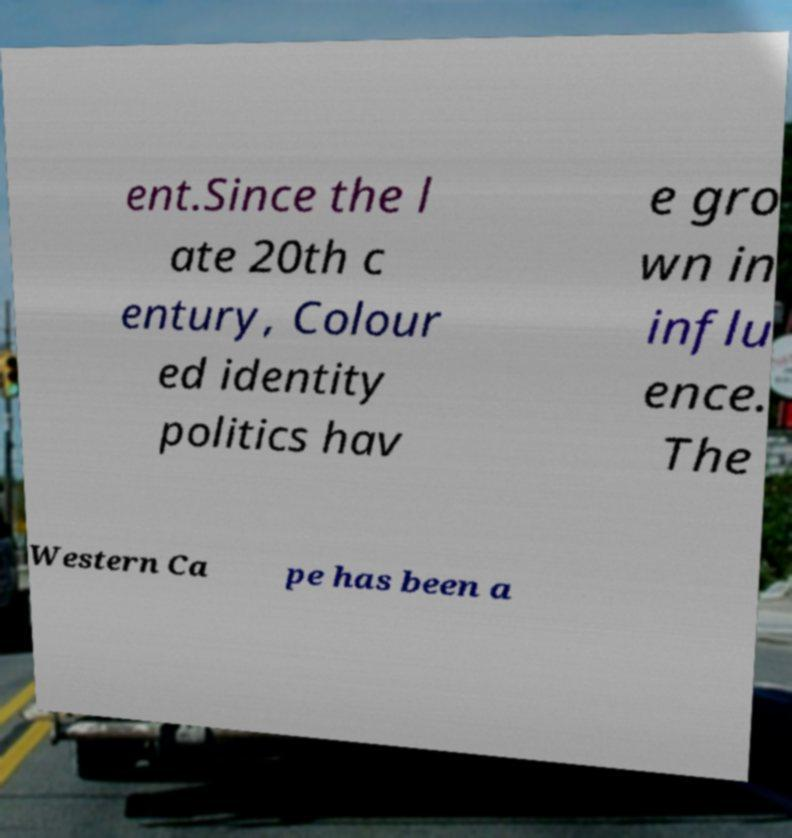What messages or text are displayed in this image? I need them in a readable, typed format. ent.Since the l ate 20th c entury, Colour ed identity politics hav e gro wn in influ ence. The Western Ca pe has been a 